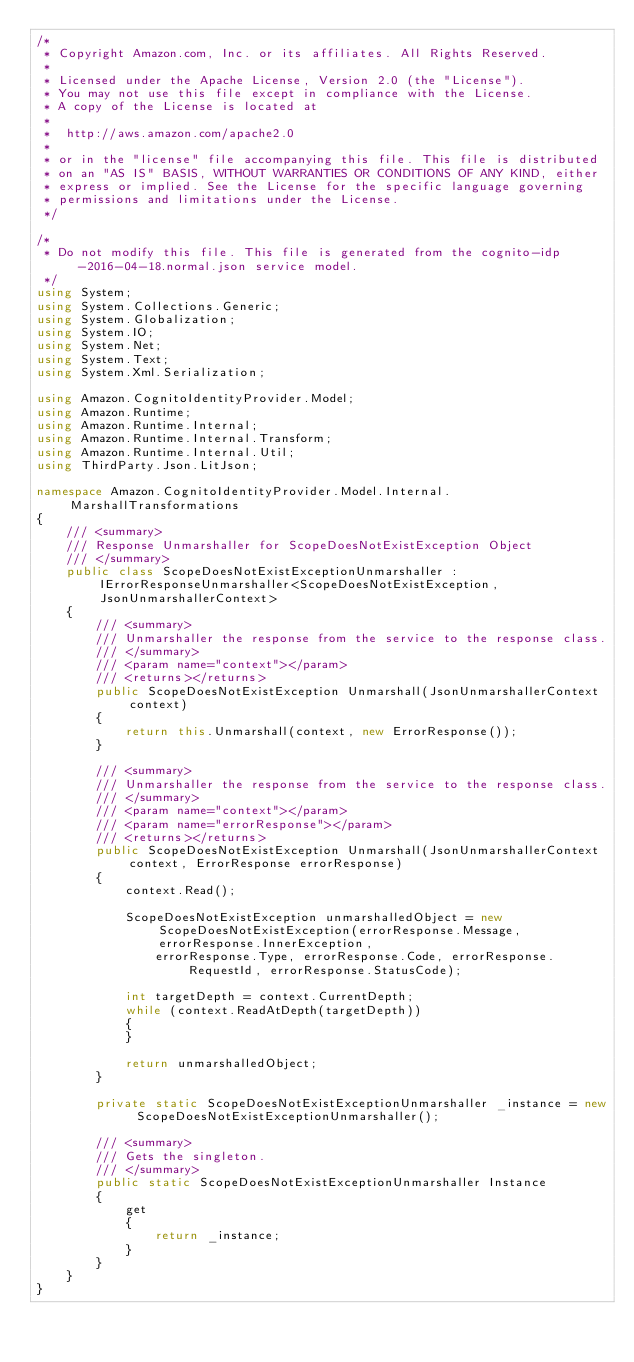Convert code to text. <code><loc_0><loc_0><loc_500><loc_500><_C#_>/*
 * Copyright Amazon.com, Inc. or its affiliates. All Rights Reserved.
 * 
 * Licensed under the Apache License, Version 2.0 (the "License").
 * You may not use this file except in compliance with the License.
 * A copy of the License is located at
 * 
 *  http://aws.amazon.com/apache2.0
 * 
 * or in the "license" file accompanying this file. This file is distributed
 * on an "AS IS" BASIS, WITHOUT WARRANTIES OR CONDITIONS OF ANY KIND, either
 * express or implied. See the License for the specific language governing
 * permissions and limitations under the License.
 */

/*
 * Do not modify this file. This file is generated from the cognito-idp-2016-04-18.normal.json service model.
 */
using System;
using System.Collections.Generic;
using System.Globalization;
using System.IO;
using System.Net;
using System.Text;
using System.Xml.Serialization;

using Amazon.CognitoIdentityProvider.Model;
using Amazon.Runtime;
using Amazon.Runtime.Internal;
using Amazon.Runtime.Internal.Transform;
using Amazon.Runtime.Internal.Util;
using ThirdParty.Json.LitJson;

namespace Amazon.CognitoIdentityProvider.Model.Internal.MarshallTransformations
{
    /// <summary>
    /// Response Unmarshaller for ScopeDoesNotExistException Object
    /// </summary>  
    public class ScopeDoesNotExistExceptionUnmarshaller : IErrorResponseUnmarshaller<ScopeDoesNotExistException, JsonUnmarshallerContext>
    {
        /// <summary>
        /// Unmarshaller the response from the service to the response class.
        /// </summary>  
        /// <param name="context"></param>
        /// <returns></returns>
        public ScopeDoesNotExistException Unmarshall(JsonUnmarshallerContext context)
        {
            return this.Unmarshall(context, new ErrorResponse());
        }

        /// <summary>
        /// Unmarshaller the response from the service to the response class.
        /// </summary>  
        /// <param name="context"></param>
        /// <param name="errorResponse"></param>
        /// <returns></returns>
        public ScopeDoesNotExistException Unmarshall(JsonUnmarshallerContext context, ErrorResponse errorResponse)
        {
            context.Read();

            ScopeDoesNotExistException unmarshalledObject = new ScopeDoesNotExistException(errorResponse.Message, errorResponse.InnerException,
                errorResponse.Type, errorResponse.Code, errorResponse.RequestId, errorResponse.StatusCode);
        
            int targetDepth = context.CurrentDepth;
            while (context.ReadAtDepth(targetDepth))
            {
            }
          
            return unmarshalledObject;
        }

        private static ScopeDoesNotExistExceptionUnmarshaller _instance = new ScopeDoesNotExistExceptionUnmarshaller();        

        /// <summary>
        /// Gets the singleton.
        /// </summary>  
        public static ScopeDoesNotExistExceptionUnmarshaller Instance
        {
            get
            {
                return _instance;
            }
        }
    }
}</code> 